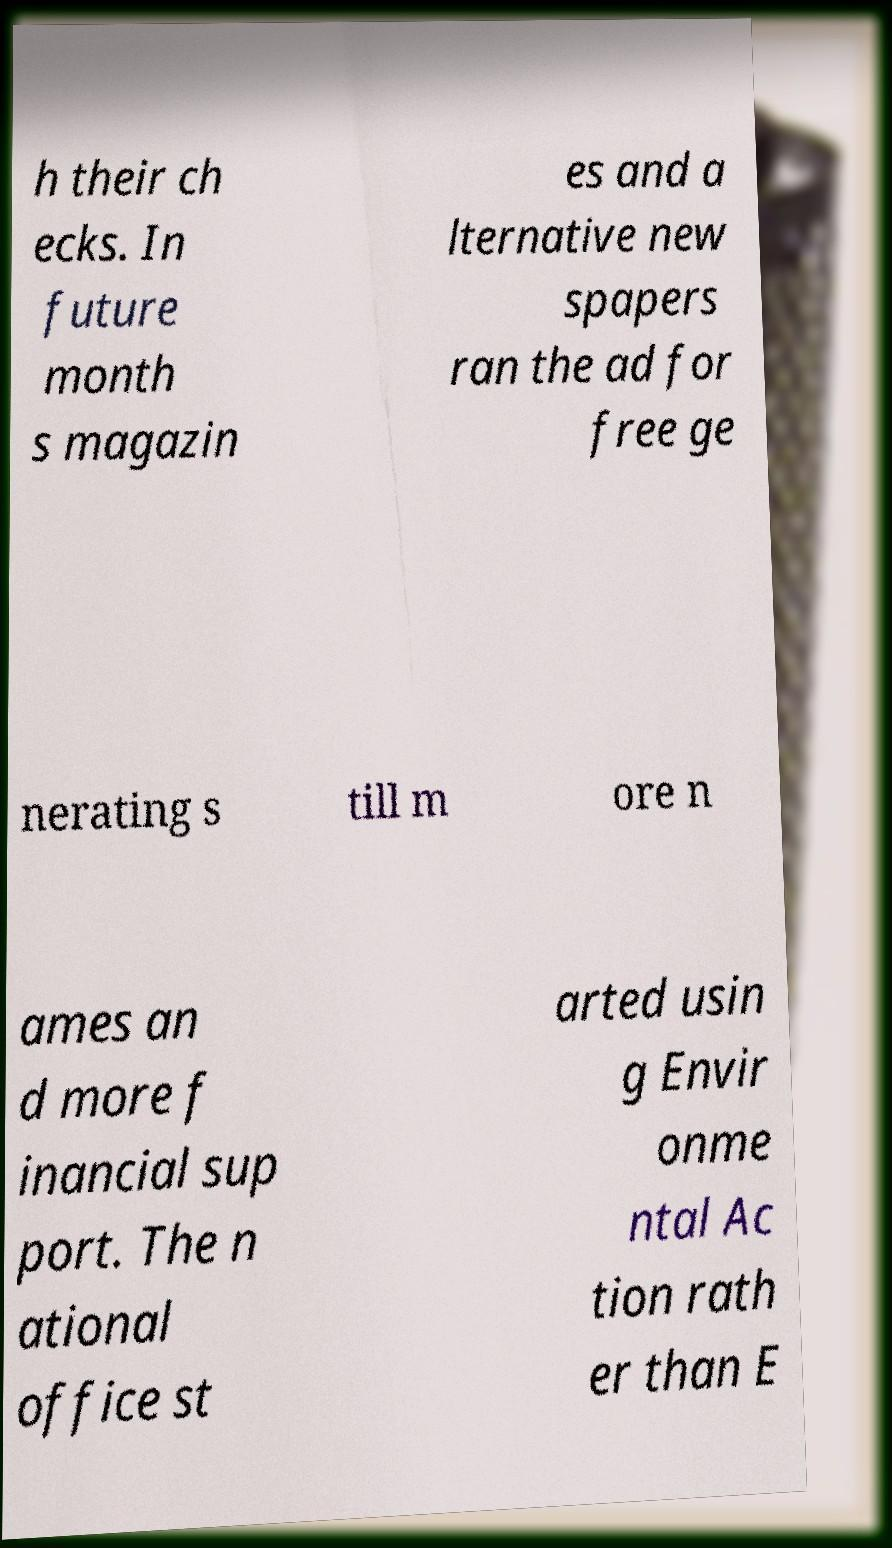What messages or text are displayed in this image? I need them in a readable, typed format. h their ch ecks. In future month s magazin es and a lternative new spapers ran the ad for free ge nerating s till m ore n ames an d more f inancial sup port. The n ational office st arted usin g Envir onme ntal Ac tion rath er than E 